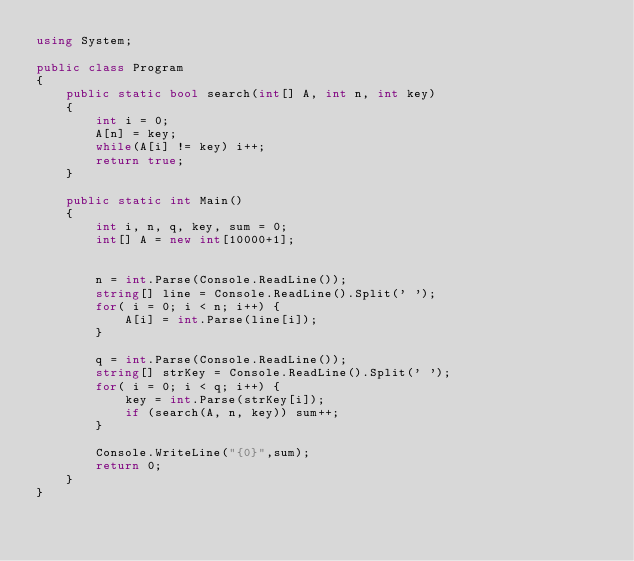<code> <loc_0><loc_0><loc_500><loc_500><_C#_>using System;

public class Program
{
	public static bool search(int[] A, int n, int key)
	{
		int i = 0;
		A[n] = key;
		while(A[i] != key) i++;
		return true;
	}

	public static int Main()
	{
		int i, n, q, key, sum = 0;
		int[] A = new int[10000+1];


		n = int.Parse(Console.ReadLine());
		string[] line = Console.ReadLine().Split(' ');
		for( i = 0; i < n; i++) {
			A[i] = int.Parse(line[i]);
		}

		q = int.Parse(Console.ReadLine());
		string[] strKey = Console.ReadLine().Split(' ');
		for( i = 0; i < q; i++) {
			key = int.Parse(strKey[i]);
			if (search(A, n, key)) sum++;
		}

		Console.WriteLine("{0}",sum);
		return 0;
	}
}</code> 